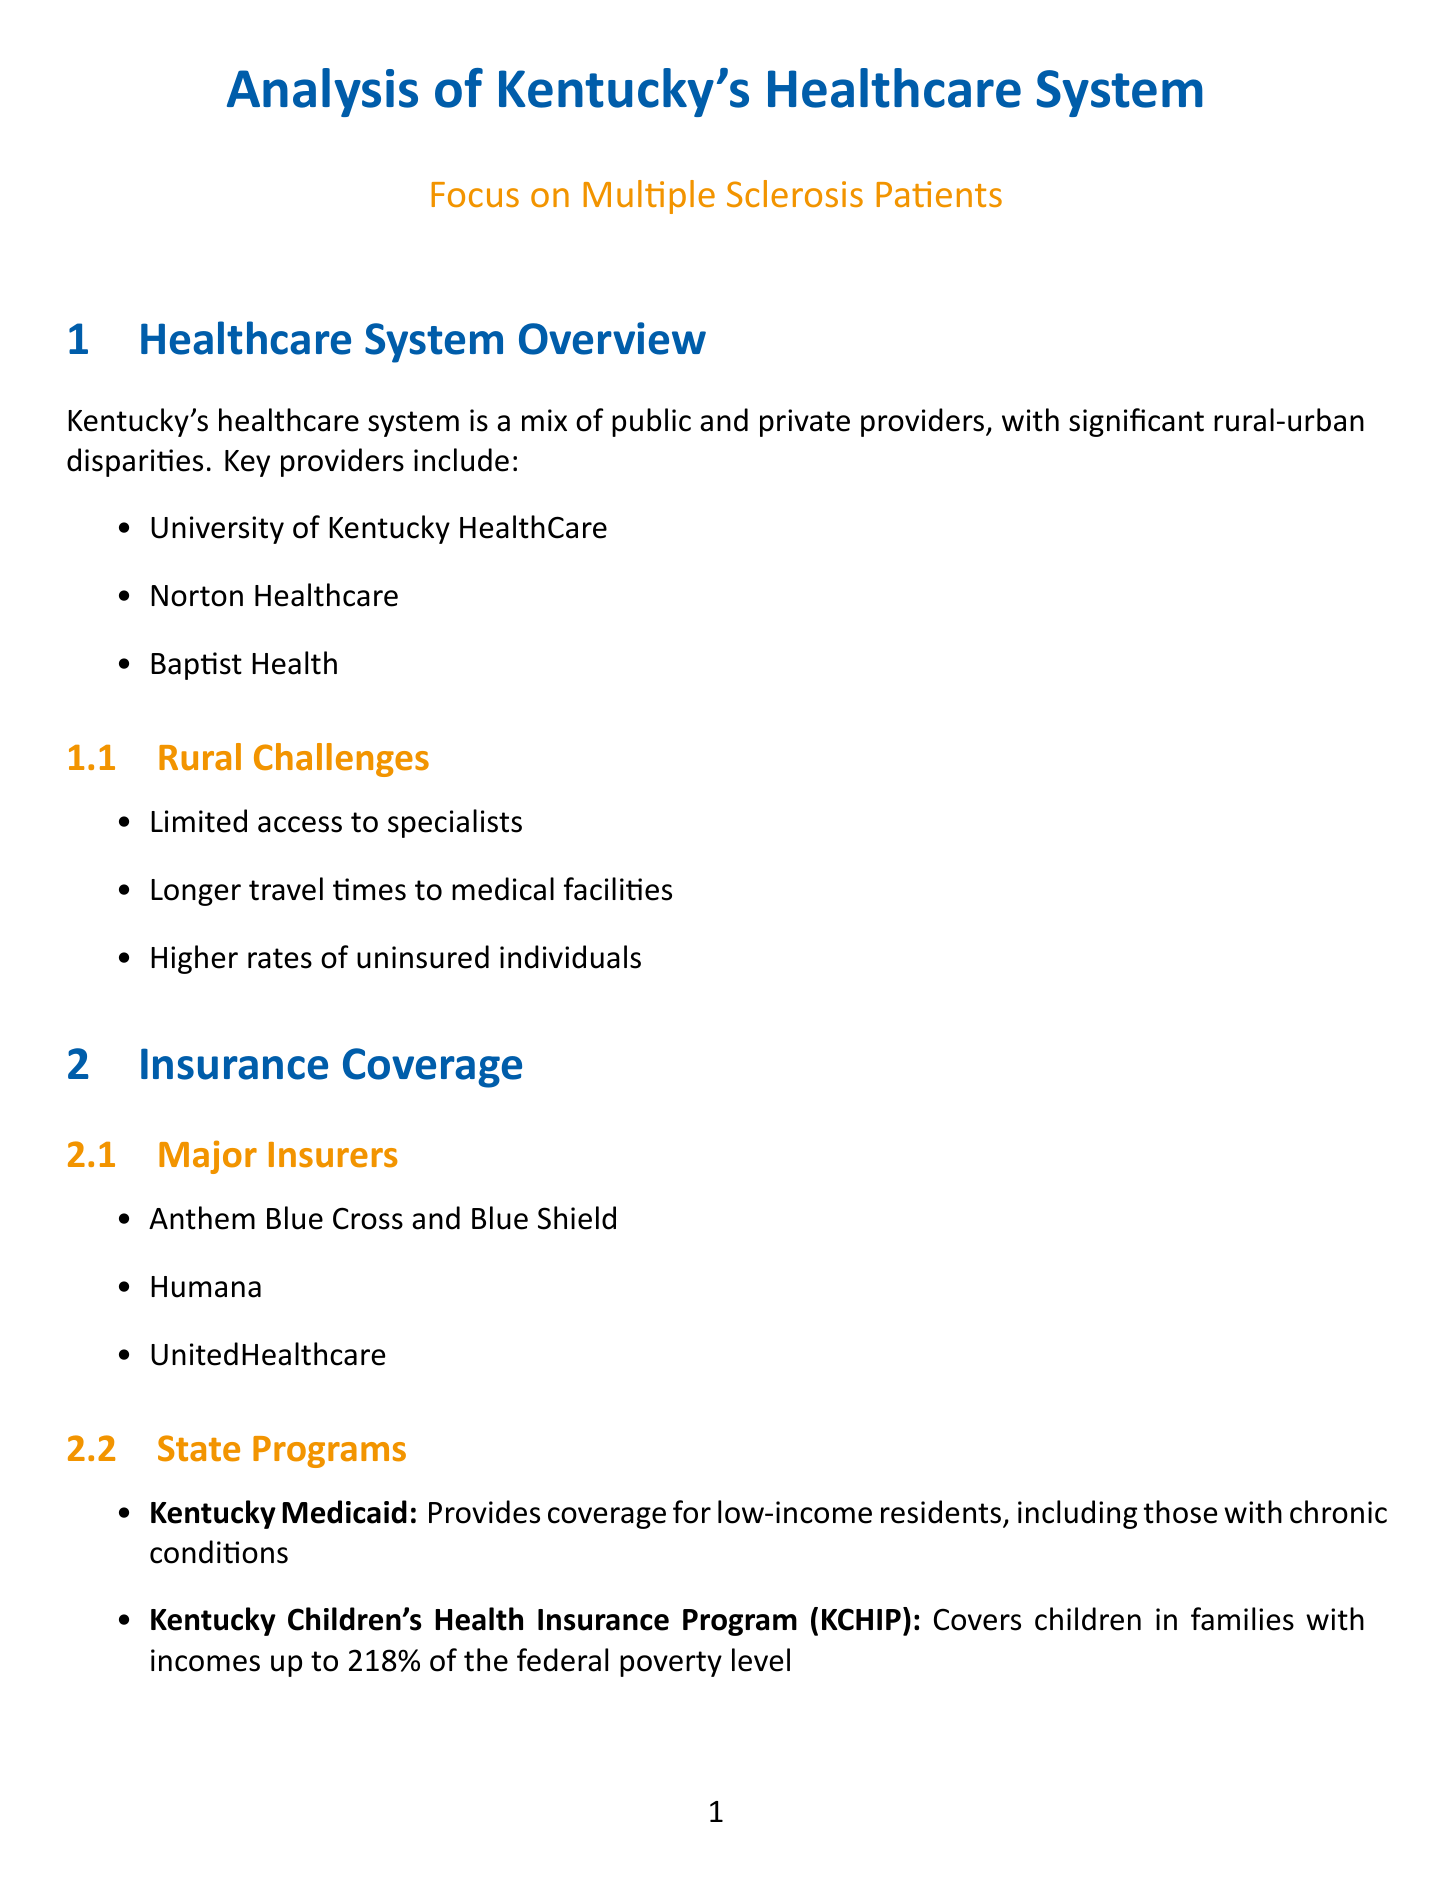what are the key providers in Kentucky's healthcare system? The key providers listed in the document include University of Kentucky HealthCare, Norton Healthcare, and Baptist Health.
Answer: University of Kentucky HealthCare, Norton Healthcare, Baptist Health how many people in Kentucky live with multiple sclerosis? The document states that approximately 4,500 people in Kentucky live with multiple sclerosis.
Answer: 4,500 what is one of the challenges for MS patients in Kentucky? The document lists several challenges for MS patients, including high cost of disease-modifying therapies.
Answer: High cost of disease-modifying therapies which state program provides coverage for low-income residents with chronic conditions? The document identifies Kentucky Medicaid as a state program that provides coverage for low-income residents, including those with chronic conditions.
Answer: Kentucky Medicaid what recent legislative change has improved access to care for rural MS patients? Recent legislation expanding telehealth services has been noted in the document as a change improving access for rural MS patients.
Answer: Telehealth who provides financial assistance for home modifications and assistive technology? The MS Society Brighter Tomorrow Grant is mentioned in the document as a program providing financial assistance for home modifications and assistive technology.
Answer: MS Society Brighter Tomorrow Grant what is one recommendation for improving MS care in Kentucky? The document recommends increasing funding for MS research in Kentucky institutions.
Answer: Increase funding for MS research in Kentucky institutions what institution focuses on neuroinflammation research in MS? The document indicates that the University of Kentucky College of Medicine focuses on neuroinflammation in MS.
Answer: University of Kentucky College of Medicine 